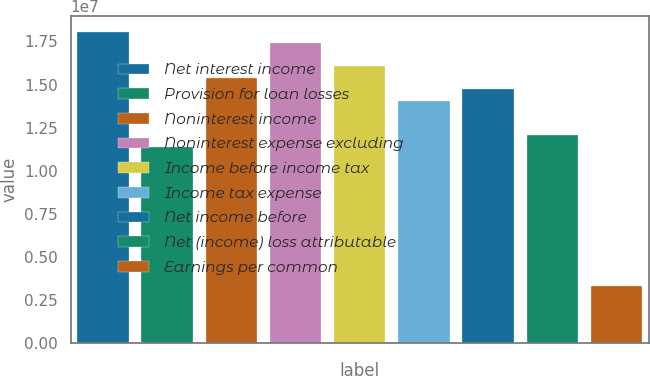Convert chart to OTSL. <chart><loc_0><loc_0><loc_500><loc_500><bar_chart><fcel>Net interest income<fcel>Provision for loan losses<fcel>Noninterest income<fcel>Noninterest expense excluding<fcel>Income before income tax<fcel>Income tax expense<fcel>Net income before<fcel>Net (income) loss attributable<fcel>Earnings per common<nl><fcel>1.80689e+07<fcel>1.13767e+07<fcel>1.5392e+07<fcel>1.73996e+07<fcel>1.60612e+07<fcel>1.40536e+07<fcel>1.47228e+07<fcel>1.20459e+07<fcel>3.34609e+06<nl></chart> 